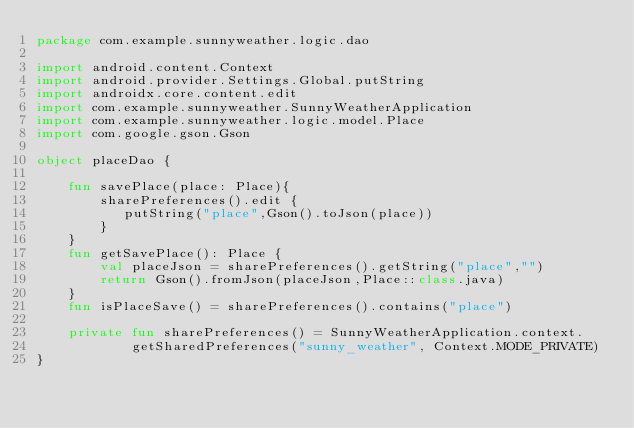Convert code to text. <code><loc_0><loc_0><loc_500><loc_500><_Kotlin_>package com.example.sunnyweather.logic.dao

import android.content.Context
import android.provider.Settings.Global.putString
import androidx.core.content.edit
import com.example.sunnyweather.SunnyWeatherApplication
import com.example.sunnyweather.logic.model.Place
import com.google.gson.Gson

object placeDao {

    fun savePlace(place: Place){
        sharePreferences().edit {
           putString("place",Gson().toJson(place))
        }
    }
    fun getSavePlace(): Place {
        val placeJson = sharePreferences().getString("place","")
        return Gson().fromJson(placeJson,Place::class.java)
    }
    fun isPlaceSave() = sharePreferences().contains("place")

    private fun sharePreferences() = SunnyWeatherApplication.context.
            getSharedPreferences("sunny_weather", Context.MODE_PRIVATE)
}</code> 